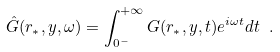<formula> <loc_0><loc_0><loc_500><loc_500>\hat { G } ( r _ { \ast } , y , \omega ) = \int _ { 0 ^ { - } } ^ { + \infty } G ( r _ { \ast } , y , t ) e ^ { i \omega t } d t \ .</formula> 